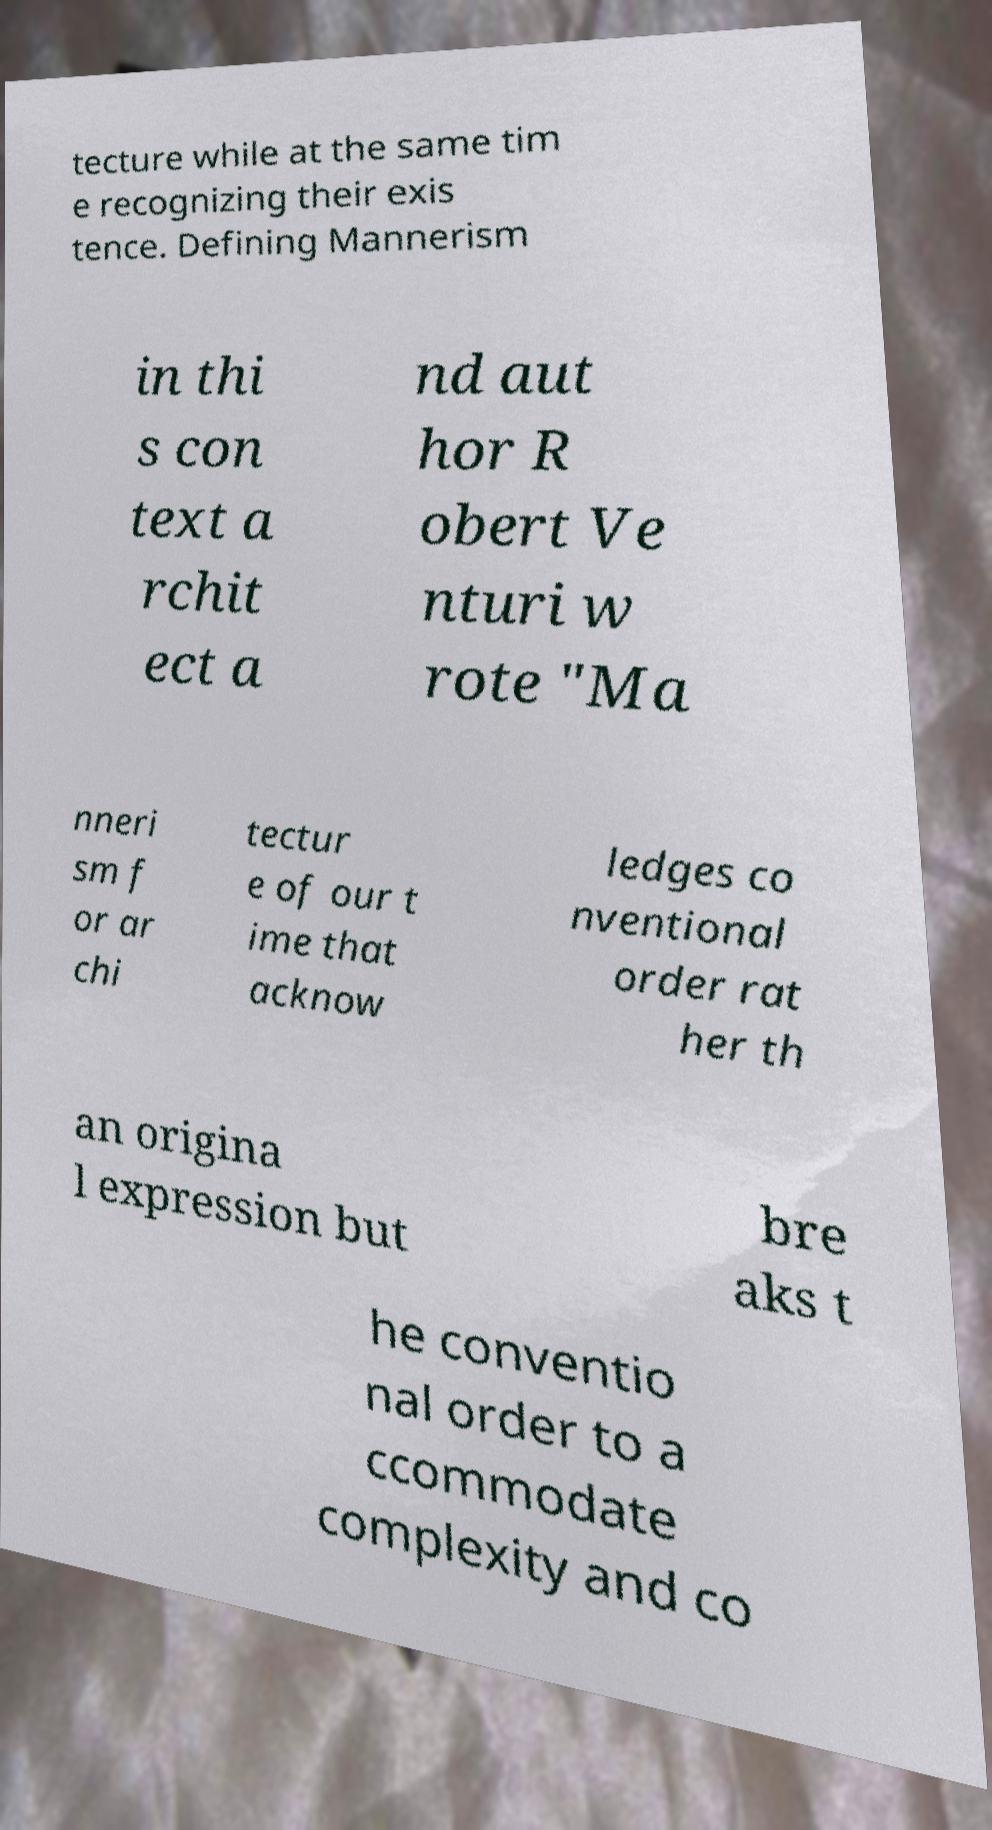Could you extract and type out the text from this image? tecture while at the same tim e recognizing their exis tence. Defining Mannerism in thi s con text a rchit ect a nd aut hor R obert Ve nturi w rote "Ma nneri sm f or ar chi tectur e of our t ime that acknow ledges co nventional order rat her th an origina l expression but bre aks t he conventio nal order to a ccommodate complexity and co 